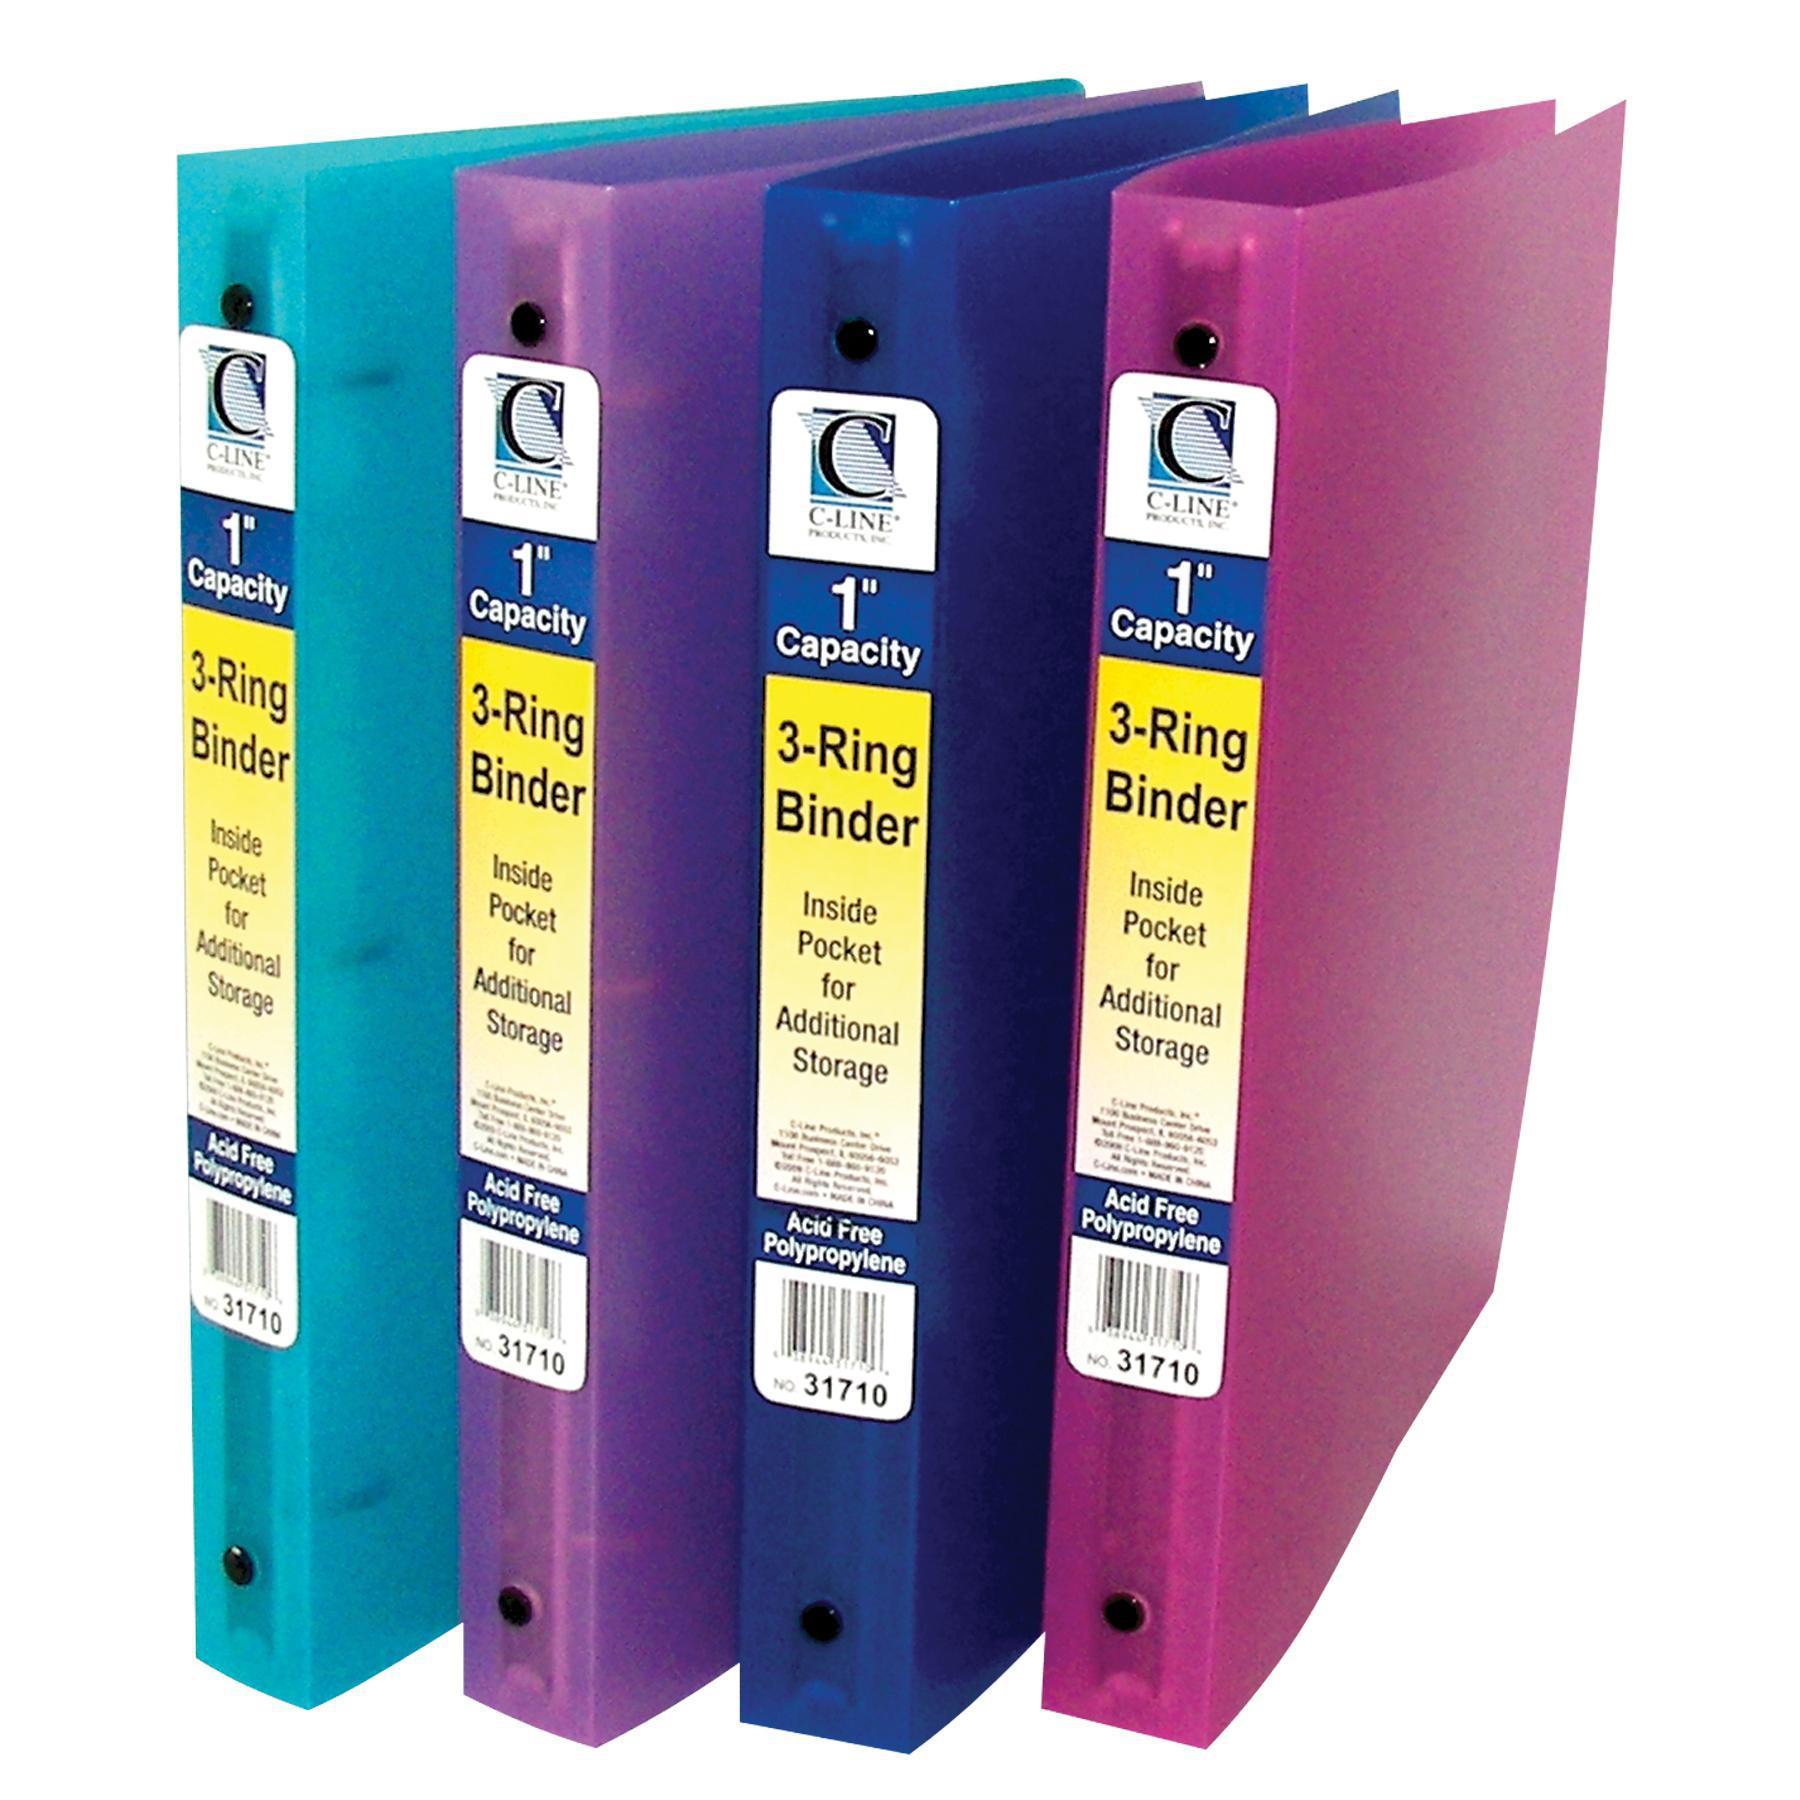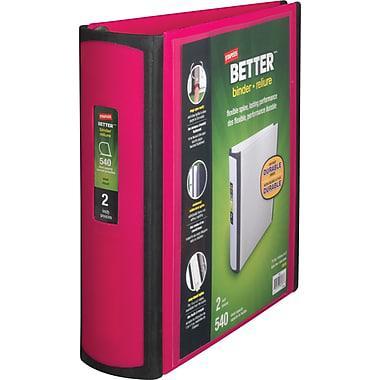The first image is the image on the left, the second image is the image on the right. Assess this claim about the two images: "The right image contains at least four binders standing vertically.". Correct or not? Answer yes or no. No. The first image is the image on the left, the second image is the image on the right. Considering the images on both sides, is "The left image contains a single binder, and the right image contains a row of upright binders with circles on the bound edges." valid? Answer yes or no. No. 